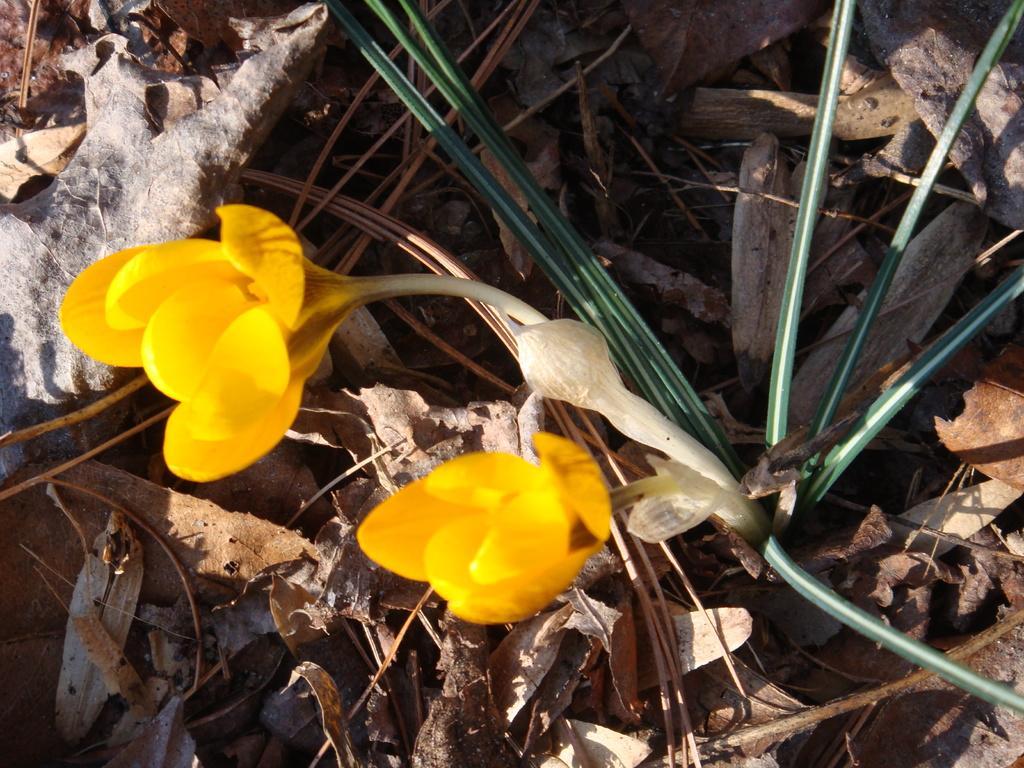In one or two sentences, can you explain what this image depicts? In this image we can see there is a plant with flowers and there are leaves on the ground. 